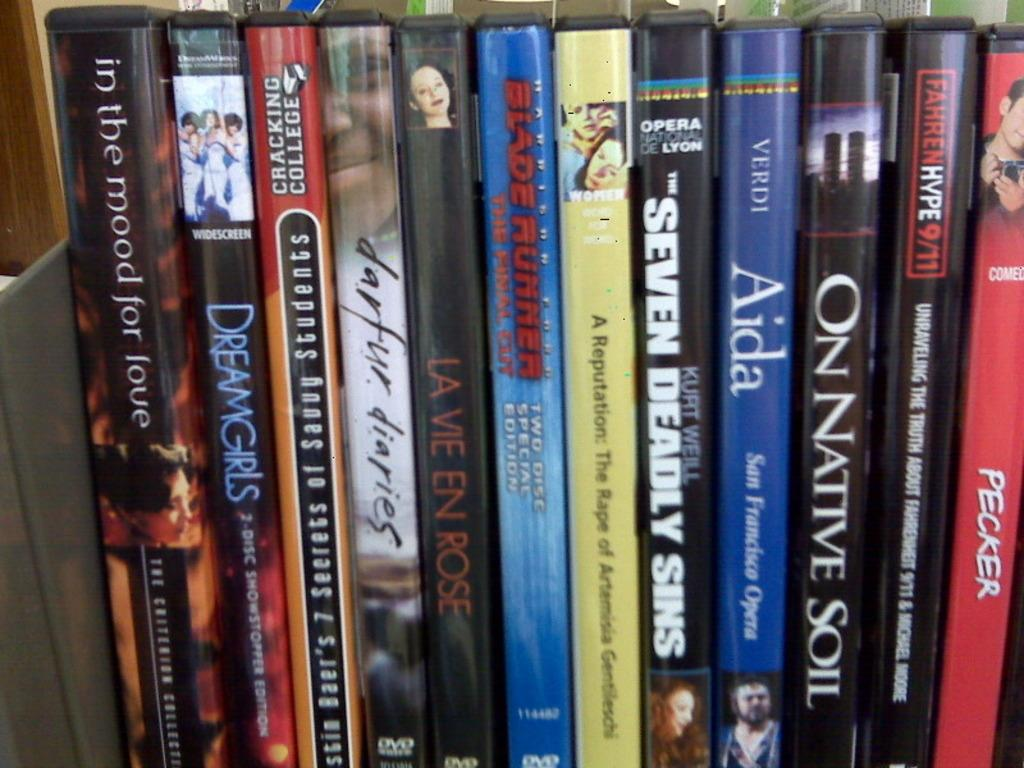<image>
Summarize the visual content of the image. A collection of DVDs on a shelf includes titles such as Dreamgirls and Seven Dead Sins. 